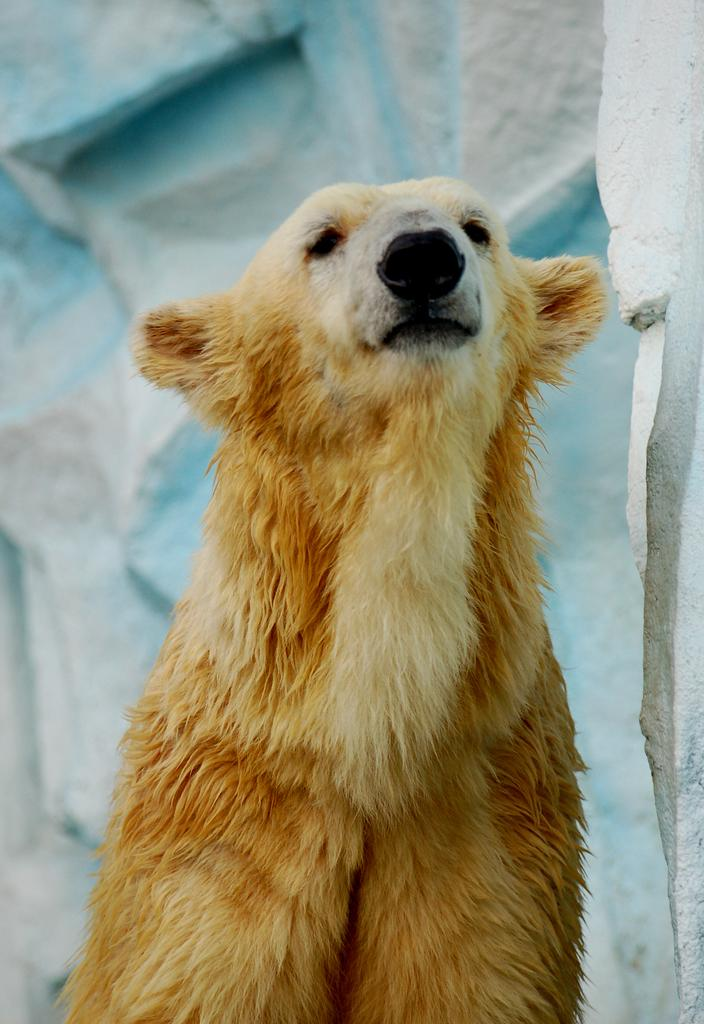What type of creature is in the image? There is an animal in the image. Can you describe the color of the animal? The animal is brown in color. What can be seen in the background of the image? There is a wall made of rocks in the background of the image. Where might this image have been taken? The image appears to be taken in a zoological park. How many boys are holding the faucet in the image? There is no faucet or boys present in the image. 